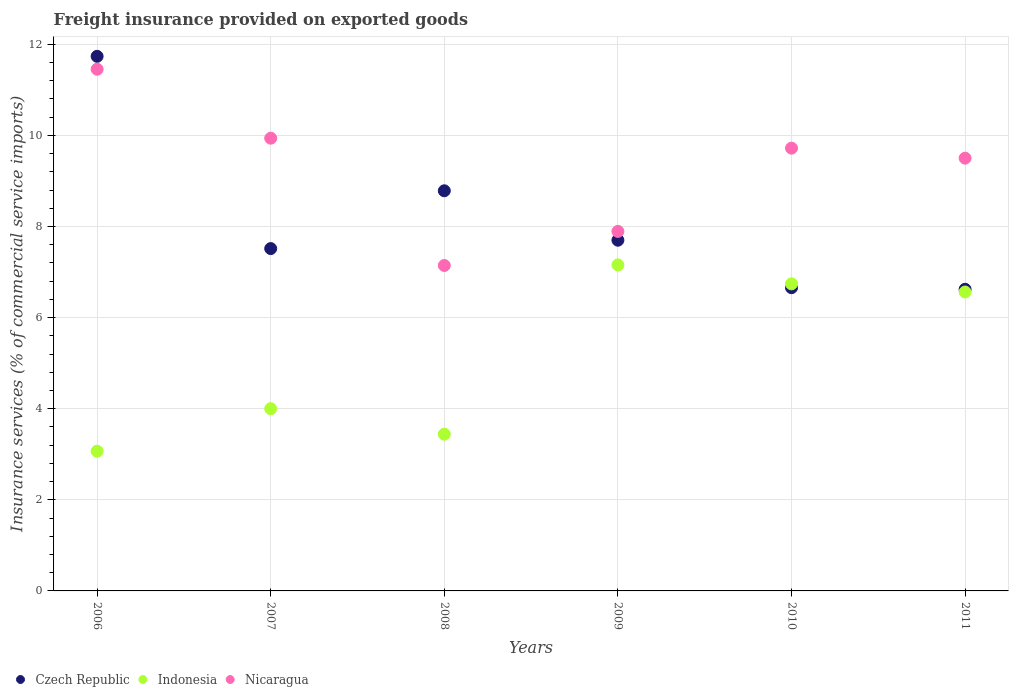How many different coloured dotlines are there?
Your answer should be very brief. 3. Is the number of dotlines equal to the number of legend labels?
Offer a terse response. Yes. What is the freight insurance provided on exported goods in Indonesia in 2011?
Offer a very short reply. 6.56. Across all years, what is the maximum freight insurance provided on exported goods in Indonesia?
Your answer should be very brief. 7.16. Across all years, what is the minimum freight insurance provided on exported goods in Nicaragua?
Your answer should be compact. 7.14. In which year was the freight insurance provided on exported goods in Indonesia maximum?
Your response must be concise. 2009. In which year was the freight insurance provided on exported goods in Nicaragua minimum?
Your answer should be very brief. 2008. What is the total freight insurance provided on exported goods in Czech Republic in the graph?
Make the answer very short. 49.01. What is the difference between the freight insurance provided on exported goods in Indonesia in 2008 and that in 2011?
Ensure brevity in your answer.  -3.12. What is the difference between the freight insurance provided on exported goods in Nicaragua in 2006 and the freight insurance provided on exported goods in Indonesia in 2007?
Your answer should be compact. 7.45. What is the average freight insurance provided on exported goods in Czech Republic per year?
Provide a short and direct response. 8.17. In the year 2011, what is the difference between the freight insurance provided on exported goods in Czech Republic and freight insurance provided on exported goods in Nicaragua?
Make the answer very short. -2.88. In how many years, is the freight insurance provided on exported goods in Nicaragua greater than 2.8 %?
Provide a succinct answer. 6. What is the ratio of the freight insurance provided on exported goods in Czech Republic in 2006 to that in 2011?
Give a very brief answer. 1.77. Is the freight insurance provided on exported goods in Indonesia in 2008 less than that in 2009?
Make the answer very short. Yes. What is the difference between the highest and the second highest freight insurance provided on exported goods in Indonesia?
Make the answer very short. 0.42. What is the difference between the highest and the lowest freight insurance provided on exported goods in Czech Republic?
Offer a terse response. 5.11. In how many years, is the freight insurance provided on exported goods in Indonesia greater than the average freight insurance provided on exported goods in Indonesia taken over all years?
Your answer should be very brief. 3. Is it the case that in every year, the sum of the freight insurance provided on exported goods in Nicaragua and freight insurance provided on exported goods in Czech Republic  is greater than the freight insurance provided on exported goods in Indonesia?
Offer a very short reply. Yes. Does the freight insurance provided on exported goods in Czech Republic monotonically increase over the years?
Give a very brief answer. No. How many dotlines are there?
Offer a terse response. 3. What is the difference between two consecutive major ticks on the Y-axis?
Provide a short and direct response. 2. Are the values on the major ticks of Y-axis written in scientific E-notation?
Give a very brief answer. No. Where does the legend appear in the graph?
Offer a very short reply. Bottom left. How are the legend labels stacked?
Provide a succinct answer. Horizontal. What is the title of the graph?
Give a very brief answer. Freight insurance provided on exported goods. What is the label or title of the X-axis?
Offer a terse response. Years. What is the label or title of the Y-axis?
Offer a very short reply. Insurance services (% of commercial service imports). What is the Insurance services (% of commercial service imports) of Czech Republic in 2006?
Offer a terse response. 11.73. What is the Insurance services (% of commercial service imports) of Indonesia in 2006?
Offer a terse response. 3.07. What is the Insurance services (% of commercial service imports) in Nicaragua in 2006?
Offer a terse response. 11.45. What is the Insurance services (% of commercial service imports) in Czech Republic in 2007?
Offer a terse response. 7.51. What is the Insurance services (% of commercial service imports) of Indonesia in 2007?
Make the answer very short. 4. What is the Insurance services (% of commercial service imports) in Nicaragua in 2007?
Keep it short and to the point. 9.94. What is the Insurance services (% of commercial service imports) of Czech Republic in 2008?
Offer a very short reply. 8.78. What is the Insurance services (% of commercial service imports) of Indonesia in 2008?
Provide a short and direct response. 3.44. What is the Insurance services (% of commercial service imports) in Nicaragua in 2008?
Offer a terse response. 7.14. What is the Insurance services (% of commercial service imports) in Czech Republic in 2009?
Your response must be concise. 7.7. What is the Insurance services (% of commercial service imports) of Indonesia in 2009?
Offer a very short reply. 7.16. What is the Insurance services (% of commercial service imports) of Nicaragua in 2009?
Keep it short and to the point. 7.89. What is the Insurance services (% of commercial service imports) in Czech Republic in 2010?
Your answer should be very brief. 6.66. What is the Insurance services (% of commercial service imports) in Indonesia in 2010?
Keep it short and to the point. 6.74. What is the Insurance services (% of commercial service imports) of Nicaragua in 2010?
Give a very brief answer. 9.72. What is the Insurance services (% of commercial service imports) of Czech Republic in 2011?
Offer a terse response. 6.62. What is the Insurance services (% of commercial service imports) of Indonesia in 2011?
Give a very brief answer. 6.56. What is the Insurance services (% of commercial service imports) in Nicaragua in 2011?
Offer a very short reply. 9.5. Across all years, what is the maximum Insurance services (% of commercial service imports) in Czech Republic?
Keep it short and to the point. 11.73. Across all years, what is the maximum Insurance services (% of commercial service imports) in Indonesia?
Keep it short and to the point. 7.16. Across all years, what is the maximum Insurance services (% of commercial service imports) of Nicaragua?
Your answer should be compact. 11.45. Across all years, what is the minimum Insurance services (% of commercial service imports) of Czech Republic?
Your answer should be compact. 6.62. Across all years, what is the minimum Insurance services (% of commercial service imports) in Indonesia?
Offer a very short reply. 3.07. Across all years, what is the minimum Insurance services (% of commercial service imports) of Nicaragua?
Your response must be concise. 7.14. What is the total Insurance services (% of commercial service imports) of Czech Republic in the graph?
Your response must be concise. 49.01. What is the total Insurance services (% of commercial service imports) in Indonesia in the graph?
Give a very brief answer. 30.97. What is the total Insurance services (% of commercial service imports) in Nicaragua in the graph?
Give a very brief answer. 55.64. What is the difference between the Insurance services (% of commercial service imports) of Czech Republic in 2006 and that in 2007?
Provide a succinct answer. 4.22. What is the difference between the Insurance services (% of commercial service imports) of Indonesia in 2006 and that in 2007?
Make the answer very short. -0.93. What is the difference between the Insurance services (% of commercial service imports) in Nicaragua in 2006 and that in 2007?
Your response must be concise. 1.51. What is the difference between the Insurance services (% of commercial service imports) of Czech Republic in 2006 and that in 2008?
Your response must be concise. 2.95. What is the difference between the Insurance services (% of commercial service imports) in Indonesia in 2006 and that in 2008?
Provide a short and direct response. -0.37. What is the difference between the Insurance services (% of commercial service imports) of Nicaragua in 2006 and that in 2008?
Your answer should be compact. 4.31. What is the difference between the Insurance services (% of commercial service imports) in Czech Republic in 2006 and that in 2009?
Keep it short and to the point. 4.04. What is the difference between the Insurance services (% of commercial service imports) in Indonesia in 2006 and that in 2009?
Offer a very short reply. -4.09. What is the difference between the Insurance services (% of commercial service imports) in Nicaragua in 2006 and that in 2009?
Your answer should be very brief. 3.56. What is the difference between the Insurance services (% of commercial service imports) in Czech Republic in 2006 and that in 2010?
Your answer should be compact. 5.08. What is the difference between the Insurance services (% of commercial service imports) in Indonesia in 2006 and that in 2010?
Your answer should be compact. -3.67. What is the difference between the Insurance services (% of commercial service imports) in Nicaragua in 2006 and that in 2010?
Provide a short and direct response. 1.73. What is the difference between the Insurance services (% of commercial service imports) of Czech Republic in 2006 and that in 2011?
Your answer should be compact. 5.11. What is the difference between the Insurance services (% of commercial service imports) in Indonesia in 2006 and that in 2011?
Offer a terse response. -3.49. What is the difference between the Insurance services (% of commercial service imports) in Nicaragua in 2006 and that in 2011?
Your answer should be compact. 1.95. What is the difference between the Insurance services (% of commercial service imports) of Czech Republic in 2007 and that in 2008?
Your response must be concise. -1.27. What is the difference between the Insurance services (% of commercial service imports) in Indonesia in 2007 and that in 2008?
Your answer should be very brief. 0.56. What is the difference between the Insurance services (% of commercial service imports) in Nicaragua in 2007 and that in 2008?
Give a very brief answer. 2.79. What is the difference between the Insurance services (% of commercial service imports) in Czech Republic in 2007 and that in 2009?
Provide a succinct answer. -0.18. What is the difference between the Insurance services (% of commercial service imports) of Indonesia in 2007 and that in 2009?
Provide a succinct answer. -3.16. What is the difference between the Insurance services (% of commercial service imports) of Nicaragua in 2007 and that in 2009?
Ensure brevity in your answer.  2.05. What is the difference between the Insurance services (% of commercial service imports) in Czech Republic in 2007 and that in 2010?
Keep it short and to the point. 0.86. What is the difference between the Insurance services (% of commercial service imports) of Indonesia in 2007 and that in 2010?
Your response must be concise. -2.74. What is the difference between the Insurance services (% of commercial service imports) in Nicaragua in 2007 and that in 2010?
Keep it short and to the point. 0.22. What is the difference between the Insurance services (% of commercial service imports) of Czech Republic in 2007 and that in 2011?
Make the answer very short. 0.89. What is the difference between the Insurance services (% of commercial service imports) in Indonesia in 2007 and that in 2011?
Keep it short and to the point. -2.56. What is the difference between the Insurance services (% of commercial service imports) in Nicaragua in 2007 and that in 2011?
Provide a short and direct response. 0.44. What is the difference between the Insurance services (% of commercial service imports) of Czech Republic in 2008 and that in 2009?
Provide a succinct answer. 1.08. What is the difference between the Insurance services (% of commercial service imports) of Indonesia in 2008 and that in 2009?
Provide a short and direct response. -3.72. What is the difference between the Insurance services (% of commercial service imports) of Nicaragua in 2008 and that in 2009?
Ensure brevity in your answer.  -0.75. What is the difference between the Insurance services (% of commercial service imports) in Czech Republic in 2008 and that in 2010?
Your response must be concise. 2.13. What is the difference between the Insurance services (% of commercial service imports) of Indonesia in 2008 and that in 2010?
Your answer should be very brief. -3.3. What is the difference between the Insurance services (% of commercial service imports) in Nicaragua in 2008 and that in 2010?
Your answer should be very brief. -2.58. What is the difference between the Insurance services (% of commercial service imports) of Czech Republic in 2008 and that in 2011?
Give a very brief answer. 2.16. What is the difference between the Insurance services (% of commercial service imports) in Indonesia in 2008 and that in 2011?
Give a very brief answer. -3.12. What is the difference between the Insurance services (% of commercial service imports) of Nicaragua in 2008 and that in 2011?
Offer a very short reply. -2.36. What is the difference between the Insurance services (% of commercial service imports) of Czech Republic in 2009 and that in 2010?
Your response must be concise. 1.04. What is the difference between the Insurance services (% of commercial service imports) of Indonesia in 2009 and that in 2010?
Your response must be concise. 0.42. What is the difference between the Insurance services (% of commercial service imports) of Nicaragua in 2009 and that in 2010?
Your answer should be very brief. -1.83. What is the difference between the Insurance services (% of commercial service imports) in Czech Republic in 2009 and that in 2011?
Make the answer very short. 1.08. What is the difference between the Insurance services (% of commercial service imports) in Indonesia in 2009 and that in 2011?
Offer a very short reply. 0.59. What is the difference between the Insurance services (% of commercial service imports) in Nicaragua in 2009 and that in 2011?
Your response must be concise. -1.61. What is the difference between the Insurance services (% of commercial service imports) of Czech Republic in 2010 and that in 2011?
Keep it short and to the point. 0.04. What is the difference between the Insurance services (% of commercial service imports) in Indonesia in 2010 and that in 2011?
Your response must be concise. 0.18. What is the difference between the Insurance services (% of commercial service imports) in Nicaragua in 2010 and that in 2011?
Provide a succinct answer. 0.22. What is the difference between the Insurance services (% of commercial service imports) in Czech Republic in 2006 and the Insurance services (% of commercial service imports) in Indonesia in 2007?
Offer a very short reply. 7.73. What is the difference between the Insurance services (% of commercial service imports) in Czech Republic in 2006 and the Insurance services (% of commercial service imports) in Nicaragua in 2007?
Provide a short and direct response. 1.8. What is the difference between the Insurance services (% of commercial service imports) in Indonesia in 2006 and the Insurance services (% of commercial service imports) in Nicaragua in 2007?
Keep it short and to the point. -6.87. What is the difference between the Insurance services (% of commercial service imports) in Czech Republic in 2006 and the Insurance services (% of commercial service imports) in Indonesia in 2008?
Ensure brevity in your answer.  8.29. What is the difference between the Insurance services (% of commercial service imports) in Czech Republic in 2006 and the Insurance services (% of commercial service imports) in Nicaragua in 2008?
Give a very brief answer. 4.59. What is the difference between the Insurance services (% of commercial service imports) of Indonesia in 2006 and the Insurance services (% of commercial service imports) of Nicaragua in 2008?
Make the answer very short. -4.08. What is the difference between the Insurance services (% of commercial service imports) in Czech Republic in 2006 and the Insurance services (% of commercial service imports) in Indonesia in 2009?
Your answer should be compact. 4.58. What is the difference between the Insurance services (% of commercial service imports) in Czech Republic in 2006 and the Insurance services (% of commercial service imports) in Nicaragua in 2009?
Offer a terse response. 3.84. What is the difference between the Insurance services (% of commercial service imports) in Indonesia in 2006 and the Insurance services (% of commercial service imports) in Nicaragua in 2009?
Provide a short and direct response. -4.82. What is the difference between the Insurance services (% of commercial service imports) in Czech Republic in 2006 and the Insurance services (% of commercial service imports) in Indonesia in 2010?
Offer a very short reply. 4.99. What is the difference between the Insurance services (% of commercial service imports) of Czech Republic in 2006 and the Insurance services (% of commercial service imports) of Nicaragua in 2010?
Offer a terse response. 2.02. What is the difference between the Insurance services (% of commercial service imports) of Indonesia in 2006 and the Insurance services (% of commercial service imports) of Nicaragua in 2010?
Keep it short and to the point. -6.65. What is the difference between the Insurance services (% of commercial service imports) in Czech Republic in 2006 and the Insurance services (% of commercial service imports) in Indonesia in 2011?
Your answer should be very brief. 5.17. What is the difference between the Insurance services (% of commercial service imports) of Czech Republic in 2006 and the Insurance services (% of commercial service imports) of Nicaragua in 2011?
Make the answer very short. 2.24. What is the difference between the Insurance services (% of commercial service imports) of Indonesia in 2006 and the Insurance services (% of commercial service imports) of Nicaragua in 2011?
Provide a succinct answer. -6.43. What is the difference between the Insurance services (% of commercial service imports) of Czech Republic in 2007 and the Insurance services (% of commercial service imports) of Indonesia in 2008?
Your response must be concise. 4.07. What is the difference between the Insurance services (% of commercial service imports) of Czech Republic in 2007 and the Insurance services (% of commercial service imports) of Nicaragua in 2008?
Your answer should be compact. 0.37. What is the difference between the Insurance services (% of commercial service imports) in Indonesia in 2007 and the Insurance services (% of commercial service imports) in Nicaragua in 2008?
Keep it short and to the point. -3.14. What is the difference between the Insurance services (% of commercial service imports) in Czech Republic in 2007 and the Insurance services (% of commercial service imports) in Indonesia in 2009?
Your answer should be very brief. 0.36. What is the difference between the Insurance services (% of commercial service imports) in Czech Republic in 2007 and the Insurance services (% of commercial service imports) in Nicaragua in 2009?
Make the answer very short. -0.38. What is the difference between the Insurance services (% of commercial service imports) in Indonesia in 2007 and the Insurance services (% of commercial service imports) in Nicaragua in 2009?
Keep it short and to the point. -3.89. What is the difference between the Insurance services (% of commercial service imports) of Czech Republic in 2007 and the Insurance services (% of commercial service imports) of Indonesia in 2010?
Offer a very short reply. 0.77. What is the difference between the Insurance services (% of commercial service imports) of Czech Republic in 2007 and the Insurance services (% of commercial service imports) of Nicaragua in 2010?
Provide a succinct answer. -2.2. What is the difference between the Insurance services (% of commercial service imports) of Indonesia in 2007 and the Insurance services (% of commercial service imports) of Nicaragua in 2010?
Offer a very short reply. -5.72. What is the difference between the Insurance services (% of commercial service imports) in Czech Republic in 2007 and the Insurance services (% of commercial service imports) in Indonesia in 2011?
Ensure brevity in your answer.  0.95. What is the difference between the Insurance services (% of commercial service imports) in Czech Republic in 2007 and the Insurance services (% of commercial service imports) in Nicaragua in 2011?
Give a very brief answer. -1.98. What is the difference between the Insurance services (% of commercial service imports) of Indonesia in 2007 and the Insurance services (% of commercial service imports) of Nicaragua in 2011?
Offer a terse response. -5.5. What is the difference between the Insurance services (% of commercial service imports) of Czech Republic in 2008 and the Insurance services (% of commercial service imports) of Indonesia in 2009?
Keep it short and to the point. 1.63. What is the difference between the Insurance services (% of commercial service imports) of Czech Republic in 2008 and the Insurance services (% of commercial service imports) of Nicaragua in 2009?
Your response must be concise. 0.89. What is the difference between the Insurance services (% of commercial service imports) in Indonesia in 2008 and the Insurance services (% of commercial service imports) in Nicaragua in 2009?
Keep it short and to the point. -4.45. What is the difference between the Insurance services (% of commercial service imports) of Czech Republic in 2008 and the Insurance services (% of commercial service imports) of Indonesia in 2010?
Your answer should be very brief. 2.04. What is the difference between the Insurance services (% of commercial service imports) of Czech Republic in 2008 and the Insurance services (% of commercial service imports) of Nicaragua in 2010?
Offer a terse response. -0.94. What is the difference between the Insurance services (% of commercial service imports) in Indonesia in 2008 and the Insurance services (% of commercial service imports) in Nicaragua in 2010?
Your response must be concise. -6.28. What is the difference between the Insurance services (% of commercial service imports) in Czech Republic in 2008 and the Insurance services (% of commercial service imports) in Indonesia in 2011?
Your answer should be compact. 2.22. What is the difference between the Insurance services (% of commercial service imports) of Czech Republic in 2008 and the Insurance services (% of commercial service imports) of Nicaragua in 2011?
Ensure brevity in your answer.  -0.72. What is the difference between the Insurance services (% of commercial service imports) of Indonesia in 2008 and the Insurance services (% of commercial service imports) of Nicaragua in 2011?
Give a very brief answer. -6.06. What is the difference between the Insurance services (% of commercial service imports) of Czech Republic in 2009 and the Insurance services (% of commercial service imports) of Indonesia in 2010?
Your answer should be very brief. 0.96. What is the difference between the Insurance services (% of commercial service imports) of Czech Republic in 2009 and the Insurance services (% of commercial service imports) of Nicaragua in 2010?
Give a very brief answer. -2.02. What is the difference between the Insurance services (% of commercial service imports) of Indonesia in 2009 and the Insurance services (% of commercial service imports) of Nicaragua in 2010?
Make the answer very short. -2.56. What is the difference between the Insurance services (% of commercial service imports) in Czech Republic in 2009 and the Insurance services (% of commercial service imports) in Indonesia in 2011?
Provide a succinct answer. 1.14. What is the difference between the Insurance services (% of commercial service imports) of Czech Republic in 2009 and the Insurance services (% of commercial service imports) of Nicaragua in 2011?
Keep it short and to the point. -1.8. What is the difference between the Insurance services (% of commercial service imports) of Indonesia in 2009 and the Insurance services (% of commercial service imports) of Nicaragua in 2011?
Offer a very short reply. -2.34. What is the difference between the Insurance services (% of commercial service imports) of Czech Republic in 2010 and the Insurance services (% of commercial service imports) of Indonesia in 2011?
Offer a very short reply. 0.09. What is the difference between the Insurance services (% of commercial service imports) of Czech Republic in 2010 and the Insurance services (% of commercial service imports) of Nicaragua in 2011?
Offer a very short reply. -2.84. What is the difference between the Insurance services (% of commercial service imports) in Indonesia in 2010 and the Insurance services (% of commercial service imports) in Nicaragua in 2011?
Your answer should be compact. -2.76. What is the average Insurance services (% of commercial service imports) in Czech Republic per year?
Your answer should be compact. 8.17. What is the average Insurance services (% of commercial service imports) of Indonesia per year?
Keep it short and to the point. 5.16. What is the average Insurance services (% of commercial service imports) of Nicaragua per year?
Your response must be concise. 9.27. In the year 2006, what is the difference between the Insurance services (% of commercial service imports) of Czech Republic and Insurance services (% of commercial service imports) of Indonesia?
Give a very brief answer. 8.67. In the year 2006, what is the difference between the Insurance services (% of commercial service imports) in Czech Republic and Insurance services (% of commercial service imports) in Nicaragua?
Offer a very short reply. 0.28. In the year 2006, what is the difference between the Insurance services (% of commercial service imports) in Indonesia and Insurance services (% of commercial service imports) in Nicaragua?
Offer a terse response. -8.38. In the year 2007, what is the difference between the Insurance services (% of commercial service imports) of Czech Republic and Insurance services (% of commercial service imports) of Indonesia?
Ensure brevity in your answer.  3.51. In the year 2007, what is the difference between the Insurance services (% of commercial service imports) of Czech Republic and Insurance services (% of commercial service imports) of Nicaragua?
Give a very brief answer. -2.42. In the year 2007, what is the difference between the Insurance services (% of commercial service imports) in Indonesia and Insurance services (% of commercial service imports) in Nicaragua?
Your response must be concise. -5.94. In the year 2008, what is the difference between the Insurance services (% of commercial service imports) of Czech Republic and Insurance services (% of commercial service imports) of Indonesia?
Your answer should be compact. 5.34. In the year 2008, what is the difference between the Insurance services (% of commercial service imports) of Czech Republic and Insurance services (% of commercial service imports) of Nicaragua?
Ensure brevity in your answer.  1.64. In the year 2008, what is the difference between the Insurance services (% of commercial service imports) of Indonesia and Insurance services (% of commercial service imports) of Nicaragua?
Your response must be concise. -3.7. In the year 2009, what is the difference between the Insurance services (% of commercial service imports) in Czech Republic and Insurance services (% of commercial service imports) in Indonesia?
Keep it short and to the point. 0.54. In the year 2009, what is the difference between the Insurance services (% of commercial service imports) of Czech Republic and Insurance services (% of commercial service imports) of Nicaragua?
Offer a terse response. -0.19. In the year 2009, what is the difference between the Insurance services (% of commercial service imports) of Indonesia and Insurance services (% of commercial service imports) of Nicaragua?
Your answer should be compact. -0.73. In the year 2010, what is the difference between the Insurance services (% of commercial service imports) of Czech Republic and Insurance services (% of commercial service imports) of Indonesia?
Offer a very short reply. -0.08. In the year 2010, what is the difference between the Insurance services (% of commercial service imports) in Czech Republic and Insurance services (% of commercial service imports) in Nicaragua?
Your answer should be very brief. -3.06. In the year 2010, what is the difference between the Insurance services (% of commercial service imports) in Indonesia and Insurance services (% of commercial service imports) in Nicaragua?
Your answer should be very brief. -2.98. In the year 2011, what is the difference between the Insurance services (% of commercial service imports) of Czech Republic and Insurance services (% of commercial service imports) of Indonesia?
Ensure brevity in your answer.  0.06. In the year 2011, what is the difference between the Insurance services (% of commercial service imports) in Czech Republic and Insurance services (% of commercial service imports) in Nicaragua?
Offer a terse response. -2.88. In the year 2011, what is the difference between the Insurance services (% of commercial service imports) of Indonesia and Insurance services (% of commercial service imports) of Nicaragua?
Offer a terse response. -2.94. What is the ratio of the Insurance services (% of commercial service imports) of Czech Republic in 2006 to that in 2007?
Your answer should be compact. 1.56. What is the ratio of the Insurance services (% of commercial service imports) of Indonesia in 2006 to that in 2007?
Provide a succinct answer. 0.77. What is the ratio of the Insurance services (% of commercial service imports) of Nicaragua in 2006 to that in 2007?
Provide a short and direct response. 1.15. What is the ratio of the Insurance services (% of commercial service imports) in Czech Republic in 2006 to that in 2008?
Ensure brevity in your answer.  1.34. What is the ratio of the Insurance services (% of commercial service imports) in Indonesia in 2006 to that in 2008?
Offer a very short reply. 0.89. What is the ratio of the Insurance services (% of commercial service imports) in Nicaragua in 2006 to that in 2008?
Keep it short and to the point. 1.6. What is the ratio of the Insurance services (% of commercial service imports) in Czech Republic in 2006 to that in 2009?
Your answer should be very brief. 1.52. What is the ratio of the Insurance services (% of commercial service imports) in Indonesia in 2006 to that in 2009?
Your response must be concise. 0.43. What is the ratio of the Insurance services (% of commercial service imports) in Nicaragua in 2006 to that in 2009?
Make the answer very short. 1.45. What is the ratio of the Insurance services (% of commercial service imports) in Czech Republic in 2006 to that in 2010?
Provide a succinct answer. 1.76. What is the ratio of the Insurance services (% of commercial service imports) in Indonesia in 2006 to that in 2010?
Give a very brief answer. 0.46. What is the ratio of the Insurance services (% of commercial service imports) in Nicaragua in 2006 to that in 2010?
Offer a very short reply. 1.18. What is the ratio of the Insurance services (% of commercial service imports) of Czech Republic in 2006 to that in 2011?
Your answer should be very brief. 1.77. What is the ratio of the Insurance services (% of commercial service imports) of Indonesia in 2006 to that in 2011?
Your answer should be very brief. 0.47. What is the ratio of the Insurance services (% of commercial service imports) in Nicaragua in 2006 to that in 2011?
Your answer should be compact. 1.21. What is the ratio of the Insurance services (% of commercial service imports) in Czech Republic in 2007 to that in 2008?
Ensure brevity in your answer.  0.86. What is the ratio of the Insurance services (% of commercial service imports) of Indonesia in 2007 to that in 2008?
Offer a very short reply. 1.16. What is the ratio of the Insurance services (% of commercial service imports) of Nicaragua in 2007 to that in 2008?
Give a very brief answer. 1.39. What is the ratio of the Insurance services (% of commercial service imports) in Czech Republic in 2007 to that in 2009?
Give a very brief answer. 0.98. What is the ratio of the Insurance services (% of commercial service imports) in Indonesia in 2007 to that in 2009?
Provide a succinct answer. 0.56. What is the ratio of the Insurance services (% of commercial service imports) in Nicaragua in 2007 to that in 2009?
Your response must be concise. 1.26. What is the ratio of the Insurance services (% of commercial service imports) in Czech Republic in 2007 to that in 2010?
Your response must be concise. 1.13. What is the ratio of the Insurance services (% of commercial service imports) in Indonesia in 2007 to that in 2010?
Your answer should be very brief. 0.59. What is the ratio of the Insurance services (% of commercial service imports) of Nicaragua in 2007 to that in 2010?
Provide a succinct answer. 1.02. What is the ratio of the Insurance services (% of commercial service imports) in Czech Republic in 2007 to that in 2011?
Offer a terse response. 1.14. What is the ratio of the Insurance services (% of commercial service imports) of Indonesia in 2007 to that in 2011?
Your answer should be very brief. 0.61. What is the ratio of the Insurance services (% of commercial service imports) in Nicaragua in 2007 to that in 2011?
Give a very brief answer. 1.05. What is the ratio of the Insurance services (% of commercial service imports) of Czech Republic in 2008 to that in 2009?
Provide a short and direct response. 1.14. What is the ratio of the Insurance services (% of commercial service imports) in Indonesia in 2008 to that in 2009?
Your response must be concise. 0.48. What is the ratio of the Insurance services (% of commercial service imports) of Nicaragua in 2008 to that in 2009?
Offer a terse response. 0.91. What is the ratio of the Insurance services (% of commercial service imports) in Czech Republic in 2008 to that in 2010?
Give a very brief answer. 1.32. What is the ratio of the Insurance services (% of commercial service imports) of Indonesia in 2008 to that in 2010?
Make the answer very short. 0.51. What is the ratio of the Insurance services (% of commercial service imports) of Nicaragua in 2008 to that in 2010?
Your response must be concise. 0.73. What is the ratio of the Insurance services (% of commercial service imports) in Czech Republic in 2008 to that in 2011?
Ensure brevity in your answer.  1.33. What is the ratio of the Insurance services (% of commercial service imports) in Indonesia in 2008 to that in 2011?
Make the answer very short. 0.52. What is the ratio of the Insurance services (% of commercial service imports) of Nicaragua in 2008 to that in 2011?
Your answer should be very brief. 0.75. What is the ratio of the Insurance services (% of commercial service imports) in Czech Republic in 2009 to that in 2010?
Give a very brief answer. 1.16. What is the ratio of the Insurance services (% of commercial service imports) of Indonesia in 2009 to that in 2010?
Offer a very short reply. 1.06. What is the ratio of the Insurance services (% of commercial service imports) of Nicaragua in 2009 to that in 2010?
Give a very brief answer. 0.81. What is the ratio of the Insurance services (% of commercial service imports) of Czech Republic in 2009 to that in 2011?
Provide a short and direct response. 1.16. What is the ratio of the Insurance services (% of commercial service imports) in Indonesia in 2009 to that in 2011?
Your answer should be very brief. 1.09. What is the ratio of the Insurance services (% of commercial service imports) in Nicaragua in 2009 to that in 2011?
Your answer should be very brief. 0.83. What is the ratio of the Insurance services (% of commercial service imports) in Czech Republic in 2010 to that in 2011?
Your response must be concise. 1.01. What is the ratio of the Insurance services (% of commercial service imports) of Indonesia in 2010 to that in 2011?
Your response must be concise. 1.03. What is the ratio of the Insurance services (% of commercial service imports) of Nicaragua in 2010 to that in 2011?
Keep it short and to the point. 1.02. What is the difference between the highest and the second highest Insurance services (% of commercial service imports) in Czech Republic?
Make the answer very short. 2.95. What is the difference between the highest and the second highest Insurance services (% of commercial service imports) in Indonesia?
Provide a short and direct response. 0.42. What is the difference between the highest and the second highest Insurance services (% of commercial service imports) in Nicaragua?
Your answer should be very brief. 1.51. What is the difference between the highest and the lowest Insurance services (% of commercial service imports) of Czech Republic?
Your answer should be compact. 5.11. What is the difference between the highest and the lowest Insurance services (% of commercial service imports) in Indonesia?
Your answer should be very brief. 4.09. What is the difference between the highest and the lowest Insurance services (% of commercial service imports) of Nicaragua?
Provide a succinct answer. 4.31. 